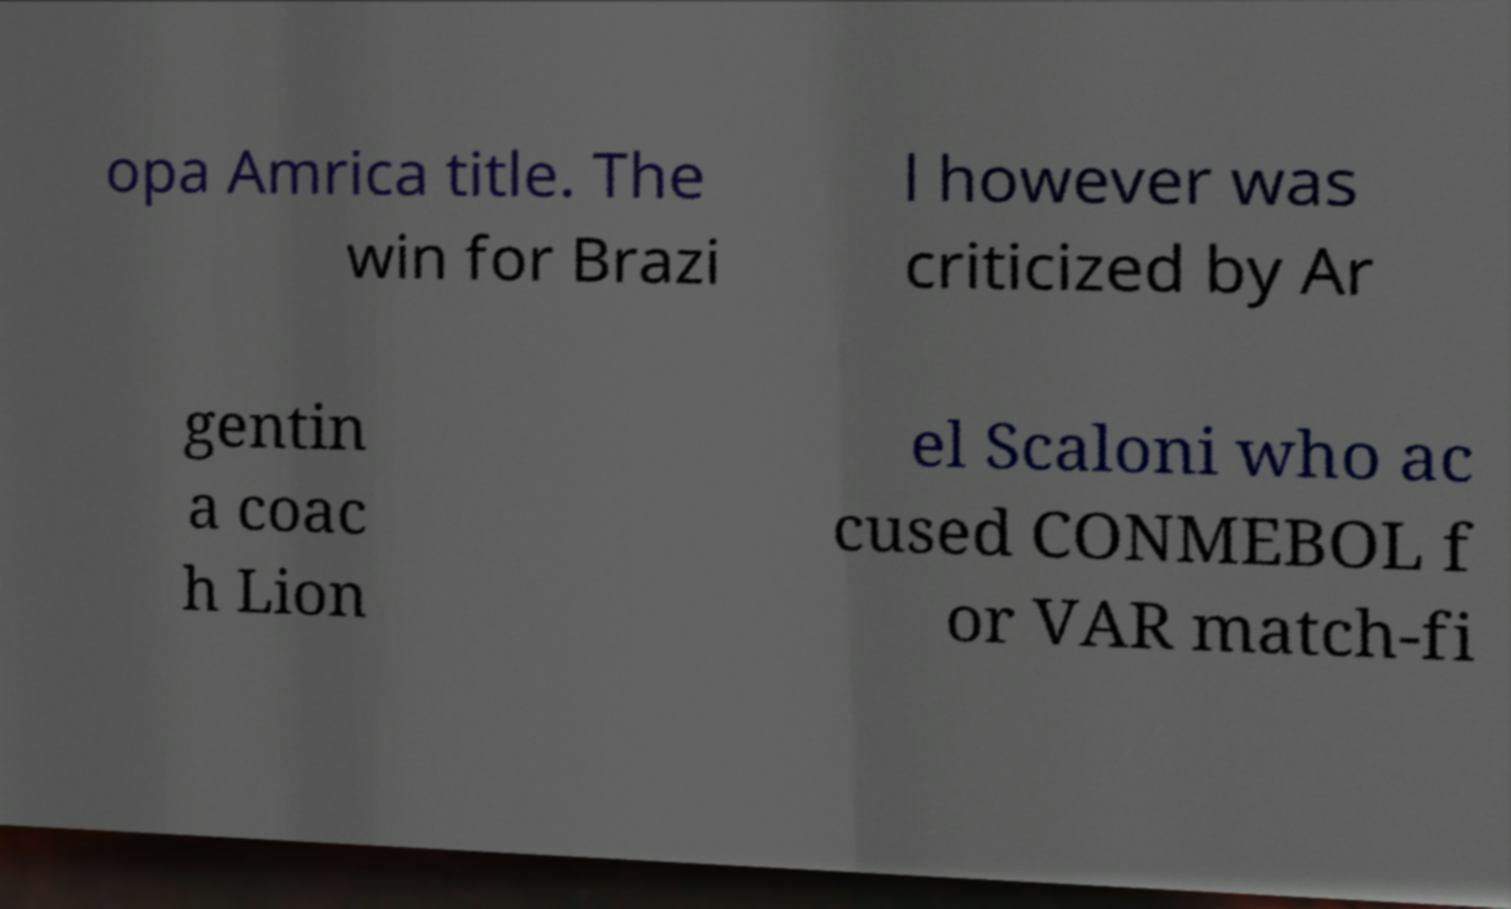Please read and relay the text visible in this image. What does it say? opa Amrica title. The win for Brazi l however was criticized by Ar gentin a coac h Lion el Scaloni who ac cused CONMEBOL f or VAR match-fi 